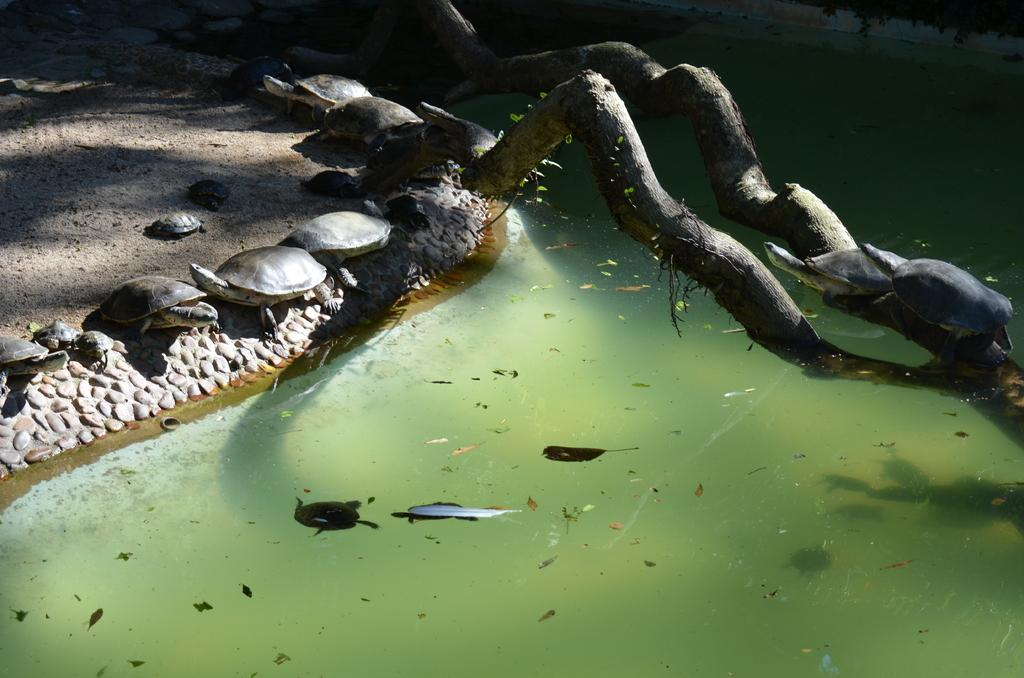What type of natural environment is depicted in the image? There is a sea in the image. What animal can be seen in the image? There is a tortoise in the image. What other land feature is visible in the image? There is land visible in the top left corner of the image. What type of vegetation is present in the image? There are trees in the image. How does the tortoise say good-bye to the other animals in the image? There are no other animals present in the image, and tortoises do not have the ability to say good-bye. 